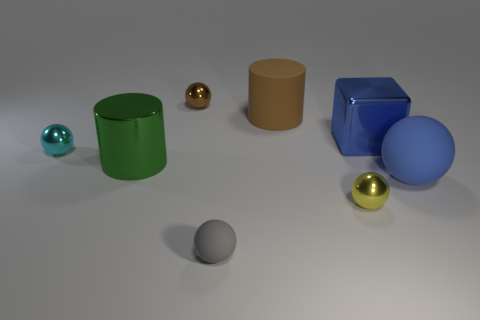Are there the same number of tiny rubber balls that are behind the gray sphere and tiny matte objects? No, the tiny rubber balls behind the gray sphere and the tiny matte objects are not equal in number. Upon closer inspection, there are noticeably fewer tiny rubber balls compared to the tiny matte objects. 